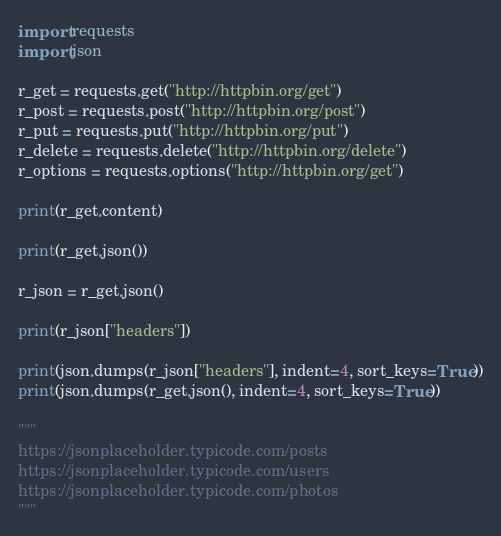<code> <loc_0><loc_0><loc_500><loc_500><_Python_>import requests
import json

r_get = requests.get("http://httpbin.org/get")
r_post = requests.post("http://httpbin.org/post")
r_put = requests.put("http://httpbin.org/put")
r_delete = requests.delete("http://httpbin.org/delete")
r_options = requests.options("http://httpbin.org/get")

print(r_get.content)

print(r_get.json())

r_json = r_get.json()

print(r_json["headers"])

print(json.dumps(r_json["headers"], indent=4, sort_keys=True))
print(json.dumps(r_get.json(), indent=4, sort_keys=True))

"""
https://jsonplaceholder.typicode.com/posts
https://jsonplaceholder.typicode.com/users
https://jsonplaceholder.typicode.com/photos
"""


</code> 